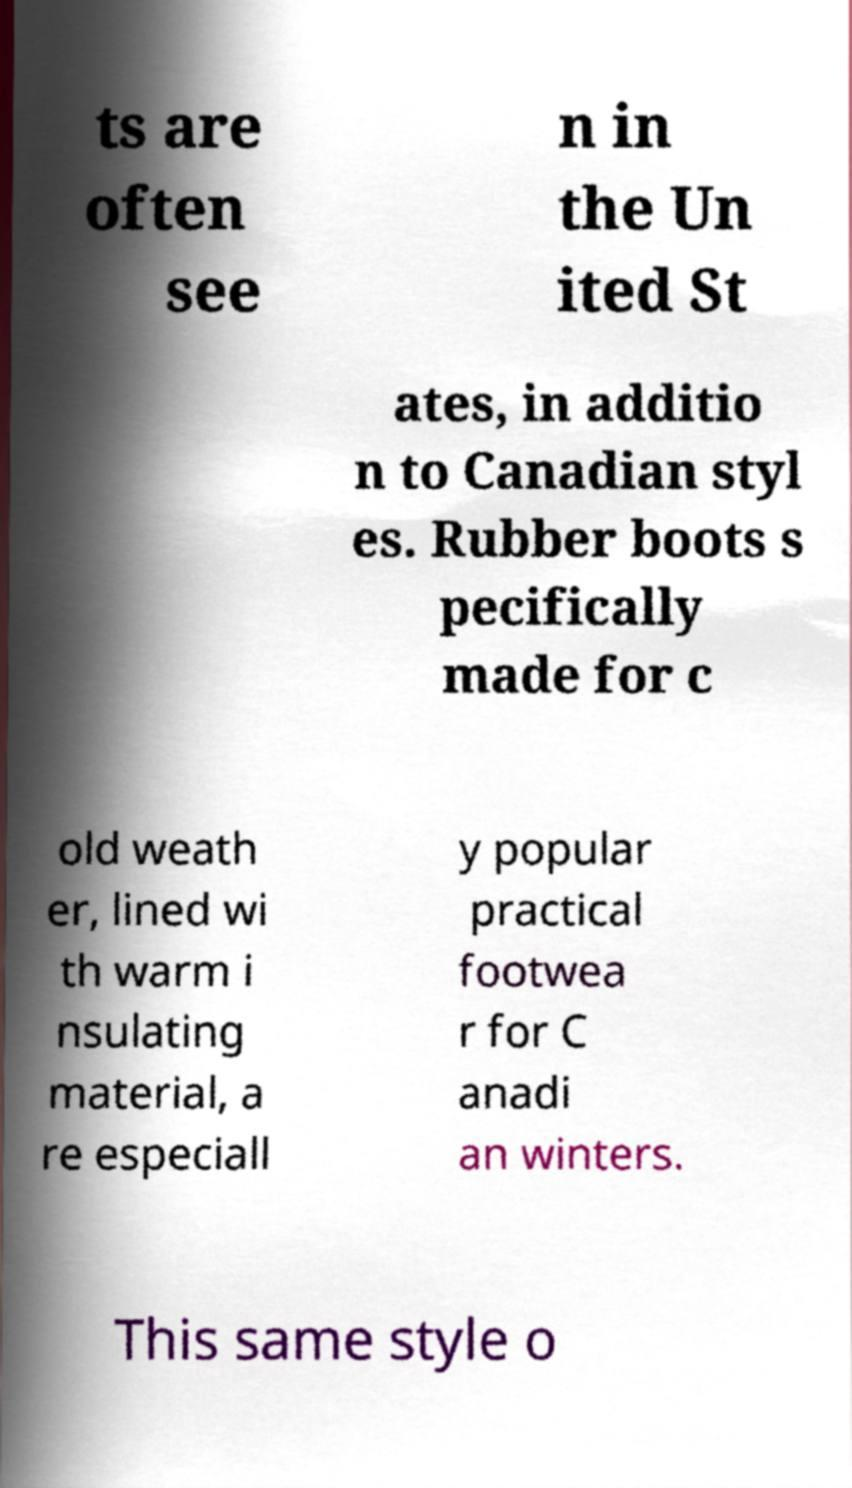Could you extract and type out the text from this image? ts are often see n in the Un ited St ates, in additio n to Canadian styl es. Rubber boots s pecifically made for c old weath er, lined wi th warm i nsulating material, a re especiall y popular practical footwea r for C anadi an winters. This same style o 